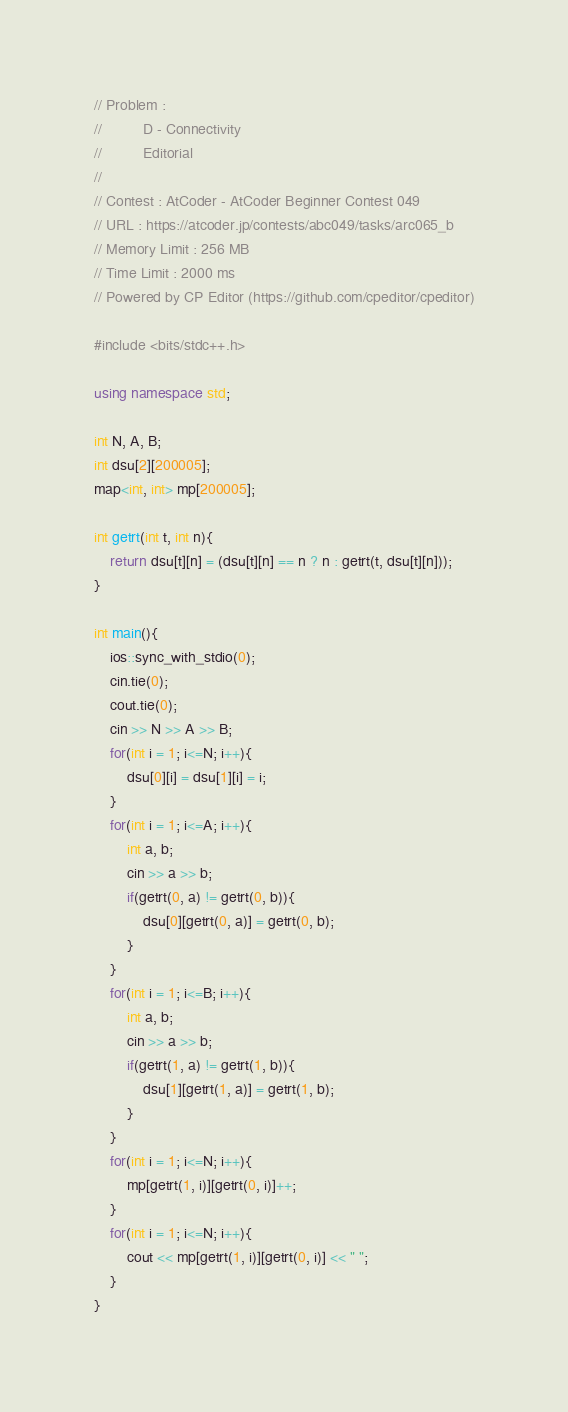<code> <loc_0><loc_0><loc_500><loc_500><_C++_>
// Problem : 
// 			D - Connectivity
// 			Editorial
// 		
// Contest : AtCoder - AtCoder Beginner Contest 049
// URL : https://atcoder.jp/contests/abc049/tasks/arc065_b
// Memory Limit : 256 MB
// Time Limit : 2000 ms
// Powered by CP Editor (https://github.com/cpeditor/cpeditor)

#include <bits/stdc++.h>

using namespace std;

int N, A, B;
int dsu[2][200005];
map<int, int> mp[200005];

int getrt(int t, int n){
	return dsu[t][n] = (dsu[t][n] == n ? n : getrt(t, dsu[t][n]));
}

int main(){
	ios::sync_with_stdio(0);
	cin.tie(0);
	cout.tie(0);
	cin >> N >> A >> B;
	for(int i = 1; i<=N; i++){
		dsu[0][i] = dsu[1][i] = i;
	}
	for(int i = 1; i<=A; i++){
		int a, b;
		cin >> a >> b;
		if(getrt(0, a) != getrt(0, b)){
			dsu[0][getrt(0, a)] = getrt(0, b);
		}
	}
	for(int i = 1; i<=B; i++){
		int a, b;
		cin >> a >> b;
		if(getrt(1, a) != getrt(1, b)){
			dsu[1][getrt(1, a)] = getrt(1, b);
		}
	}
	for(int i = 1; i<=N; i++){
		mp[getrt(1, i)][getrt(0, i)]++;
	}
	for(int i = 1; i<=N; i++){
		cout << mp[getrt(1, i)][getrt(0, i)] << " ";
	}
}</code> 